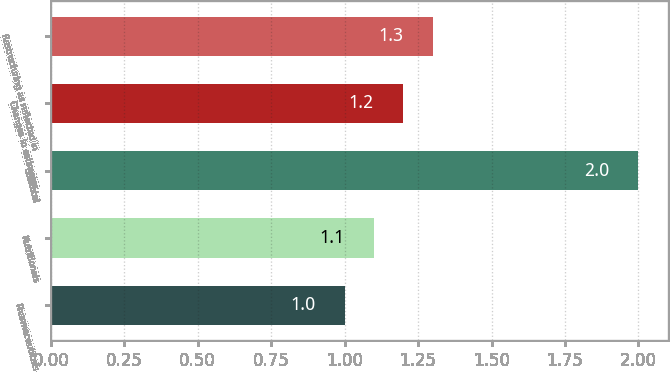Convert chart. <chart><loc_0><loc_0><loc_500><loc_500><bar_chart><fcel>Pharmaceuticals<fcel>Nutritionals<fcel>Subtotal<fcel>Changes in estimates<fcel>Restructuring as reflected in<nl><fcel>1<fcel>1.1<fcel>2<fcel>1.2<fcel>1.3<nl></chart> 